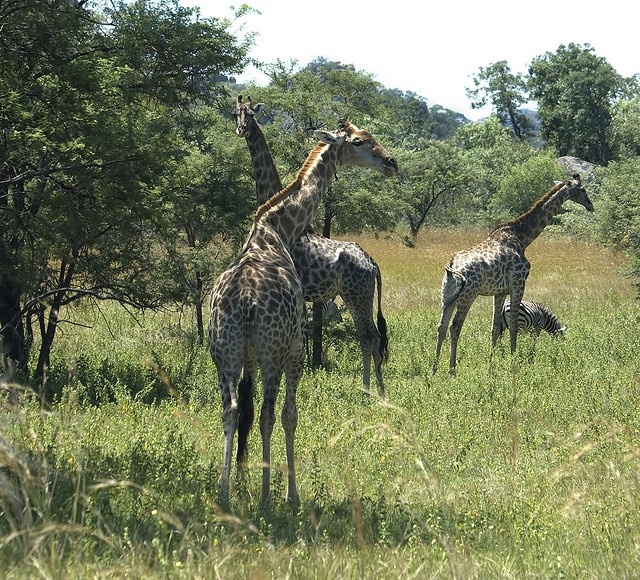Describe the objects in this image and their specific colors. I can see giraffe in black, gray, darkgreen, and tan tones, giraffe in black, gray, darkgreen, and ivory tones, giraffe in black, gray, darkgray, and darkgreen tones, zebra in black, gray, darkgray, and ivory tones, and zebra in black, gray, and darkgray tones in this image. 